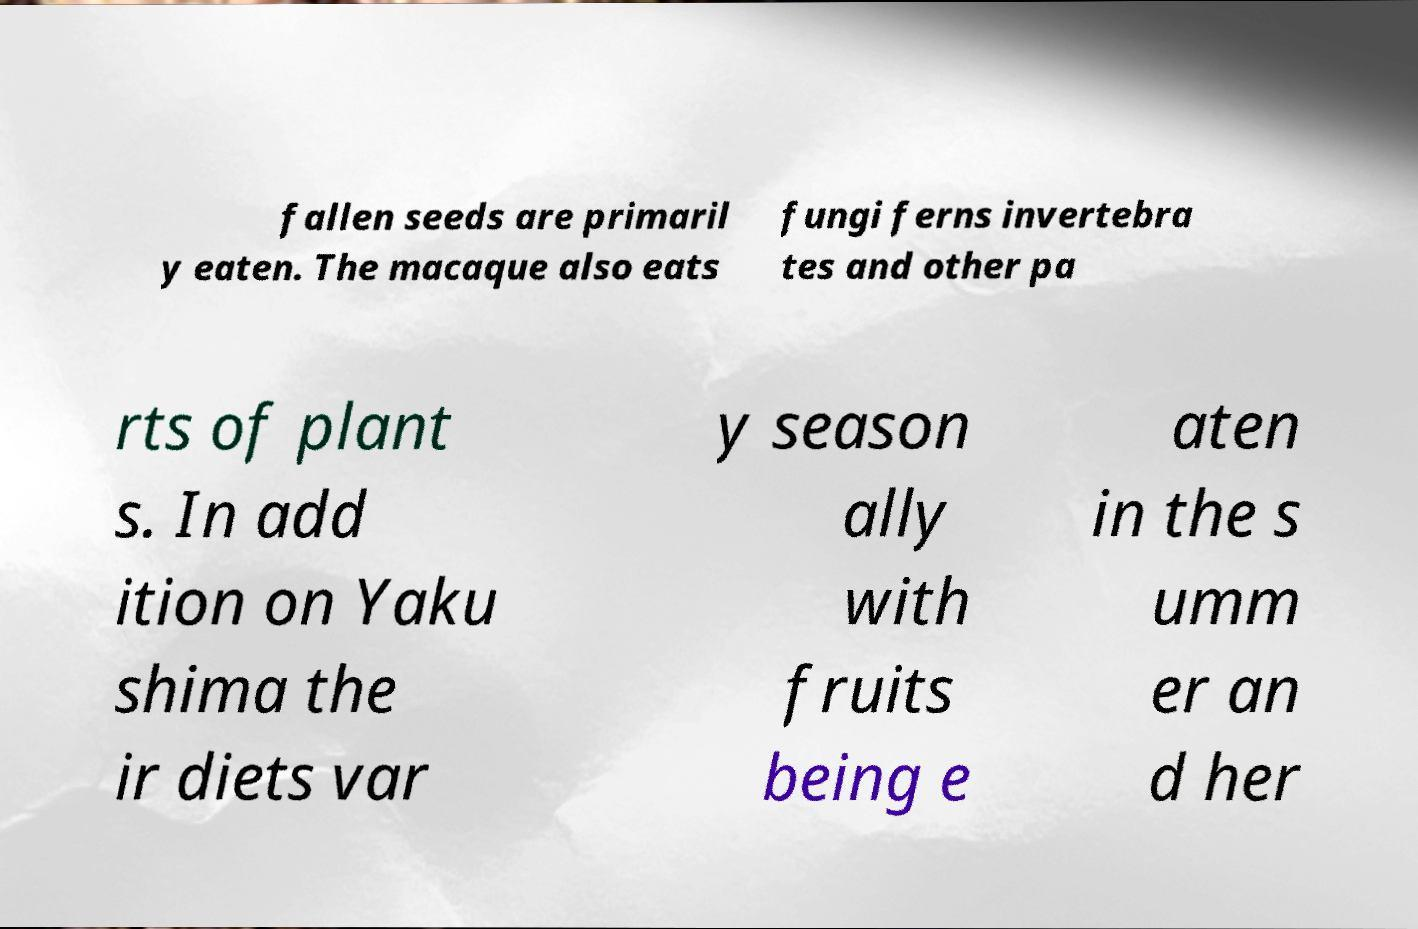There's text embedded in this image that I need extracted. Can you transcribe it verbatim? fallen seeds are primaril y eaten. The macaque also eats fungi ferns invertebra tes and other pa rts of plant s. In add ition on Yaku shima the ir diets var y season ally with fruits being e aten in the s umm er an d her 